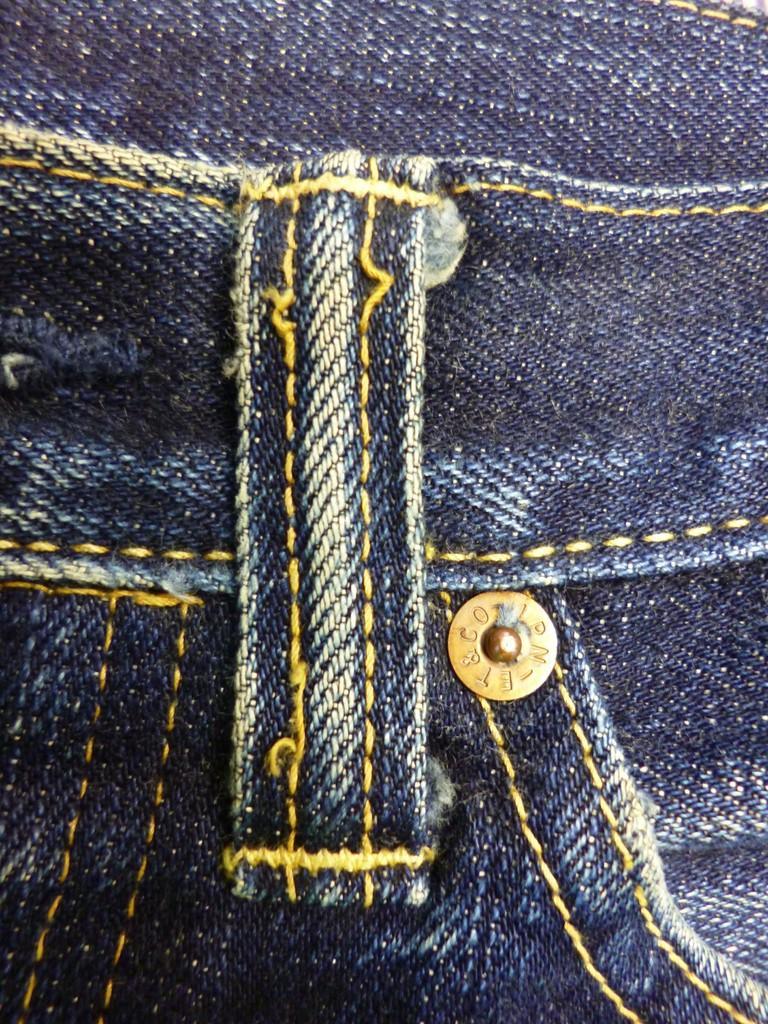How would you summarize this image in a sentence or two? In this image there is a jeans. 